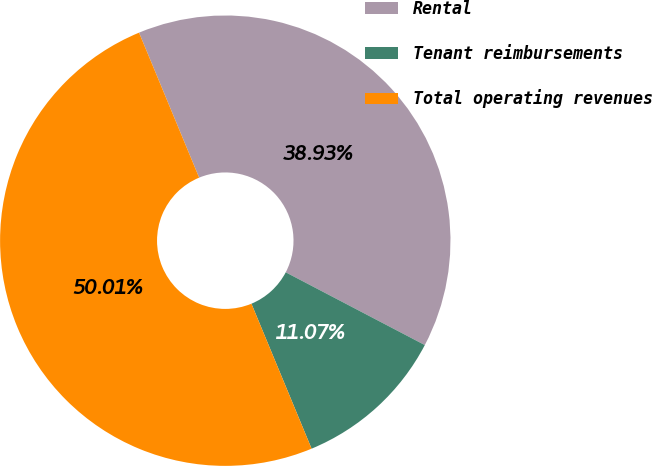<chart> <loc_0><loc_0><loc_500><loc_500><pie_chart><fcel>Rental<fcel>Tenant reimbursements<fcel>Total operating revenues<nl><fcel>38.93%<fcel>11.07%<fcel>50.01%<nl></chart> 